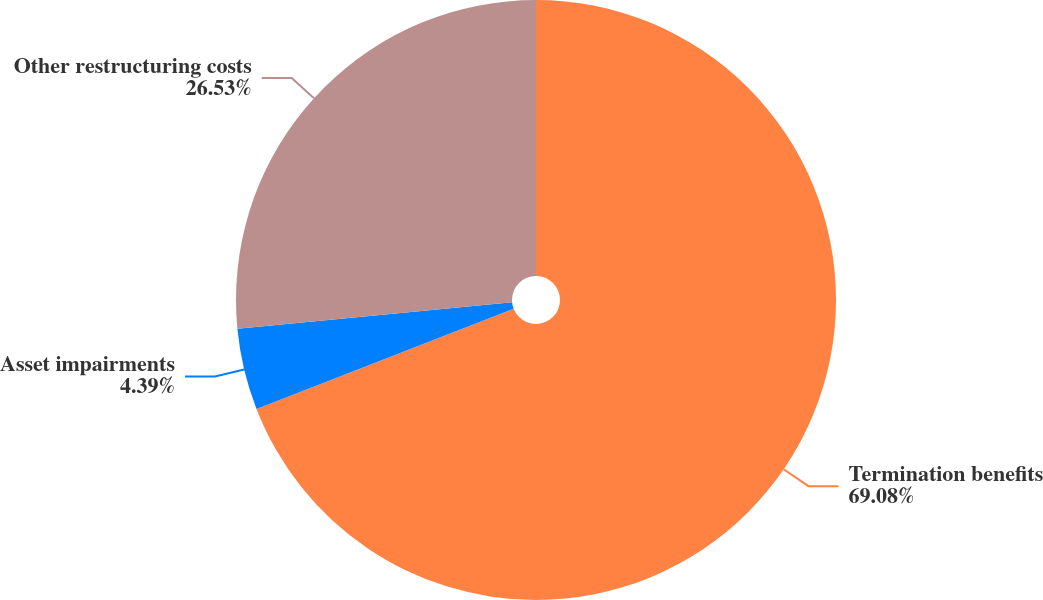Convert chart to OTSL. <chart><loc_0><loc_0><loc_500><loc_500><pie_chart><fcel>Termination benefits<fcel>Asset impairments<fcel>Other restructuring costs<nl><fcel>69.09%<fcel>4.39%<fcel>26.53%<nl></chart> 